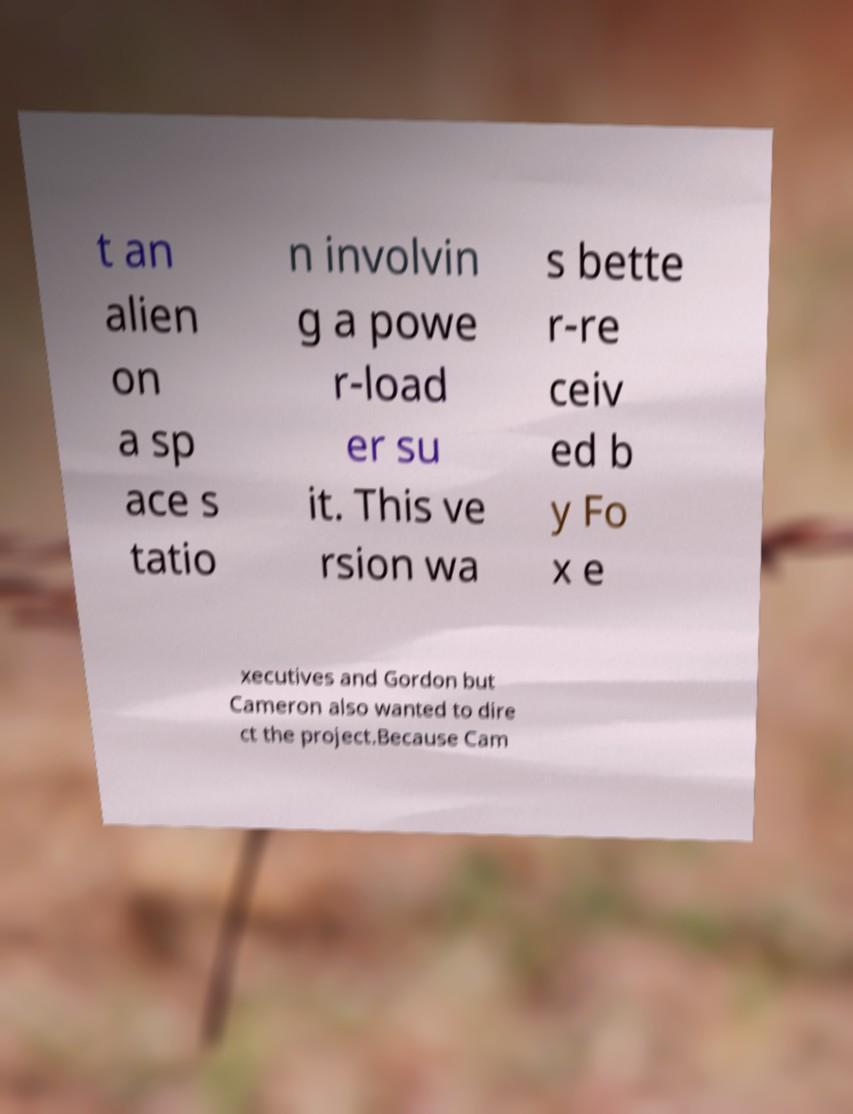Could you assist in decoding the text presented in this image and type it out clearly? t an alien on a sp ace s tatio n involvin g a powe r-load er su it. This ve rsion wa s bette r-re ceiv ed b y Fo x e xecutives and Gordon but Cameron also wanted to dire ct the project.Because Cam 